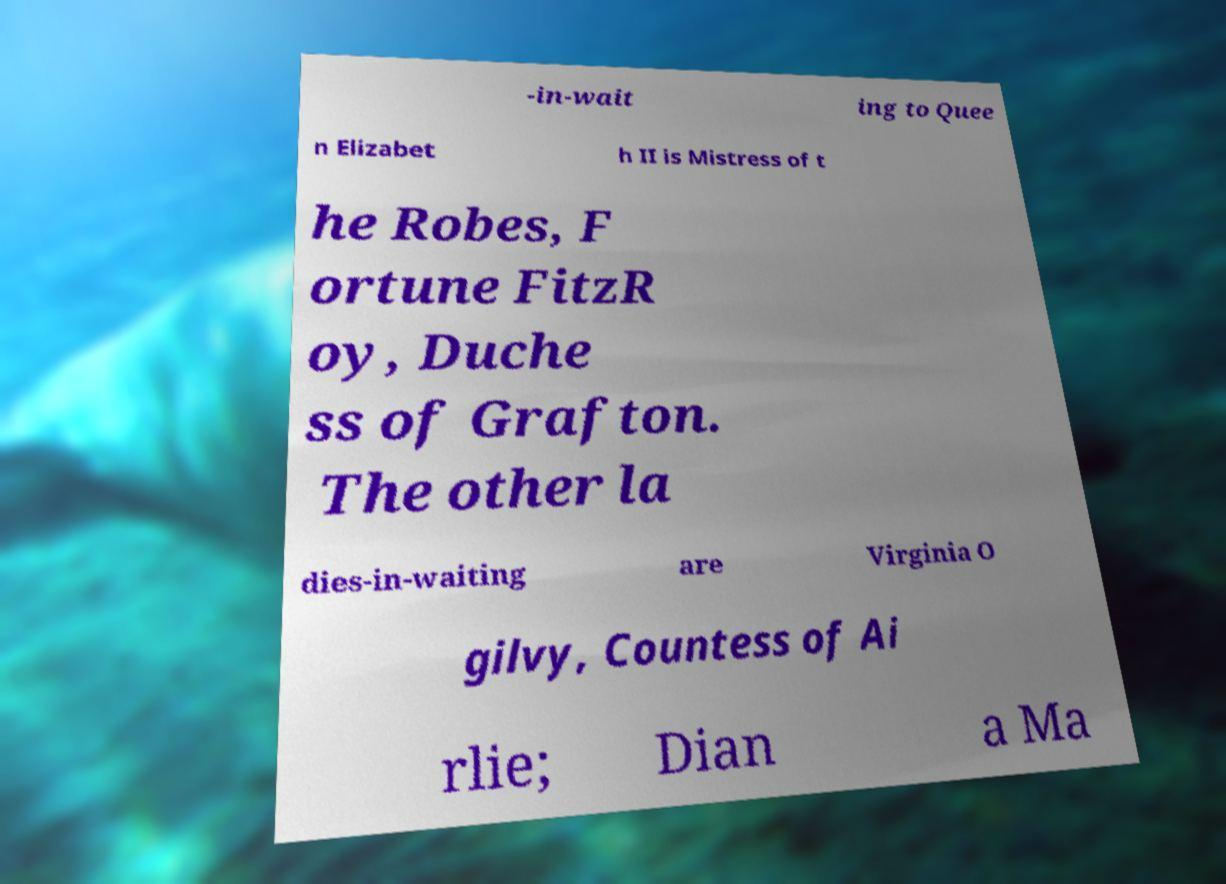Could you extract and type out the text from this image? -in-wait ing to Quee n Elizabet h II is Mistress of t he Robes, F ortune FitzR oy, Duche ss of Grafton. The other la dies-in-waiting are Virginia O gilvy, Countess of Ai rlie; Dian a Ma 